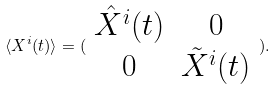Convert formula to latex. <formula><loc_0><loc_0><loc_500><loc_500>\langle X ^ { i } ( t ) \rangle = ( \begin{array} { c c } \hat { X } ^ { i } ( t ) & 0 \\ 0 & \tilde { X } ^ { i } ( t ) \end{array} ) .</formula> 